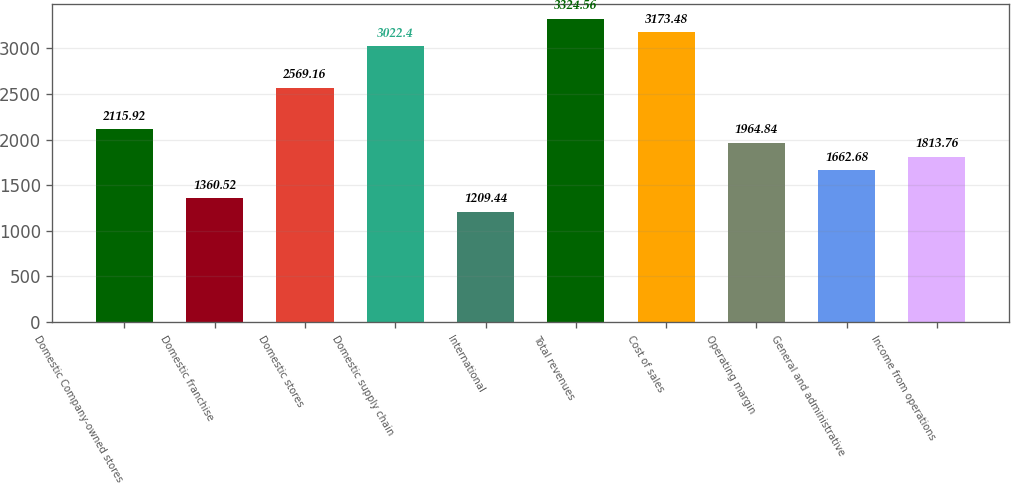Convert chart. <chart><loc_0><loc_0><loc_500><loc_500><bar_chart><fcel>Domestic Company-owned stores<fcel>Domestic franchise<fcel>Domestic stores<fcel>Domestic supply chain<fcel>International<fcel>Total revenues<fcel>Cost of sales<fcel>Operating margin<fcel>General and administrative<fcel>Income from operations<nl><fcel>2115.92<fcel>1360.52<fcel>2569.16<fcel>3022.4<fcel>1209.44<fcel>3324.56<fcel>3173.48<fcel>1964.84<fcel>1662.68<fcel>1813.76<nl></chart> 